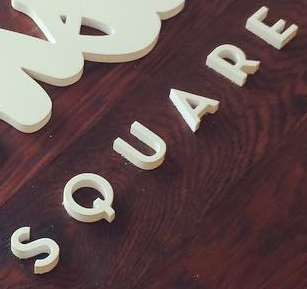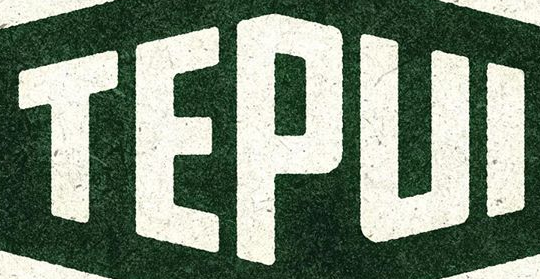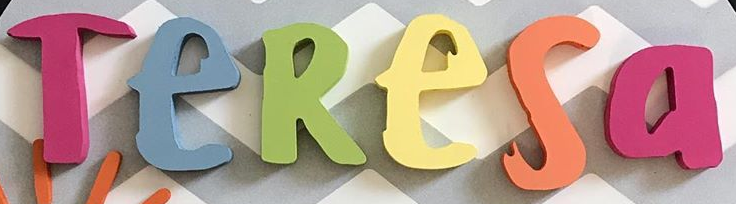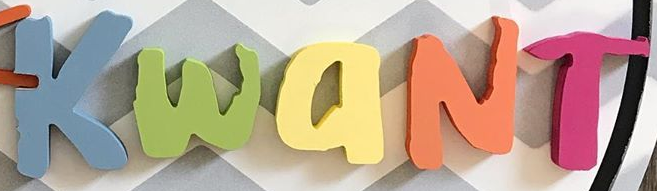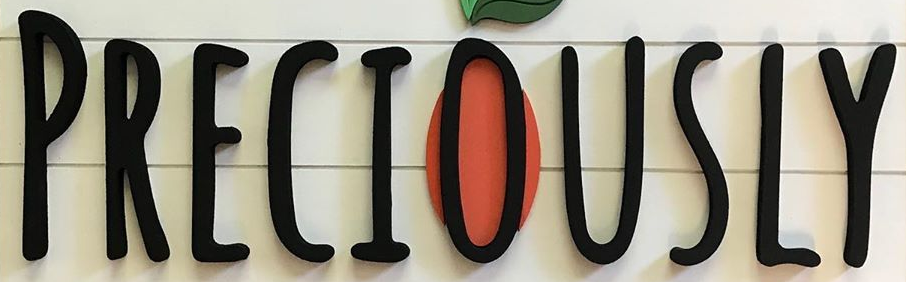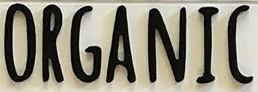Identify the words shown in these images in order, separated by a semicolon. SQUARE; TEPUI; TeResa; KwaNT; PRECIOUSLY; ORGANIC 